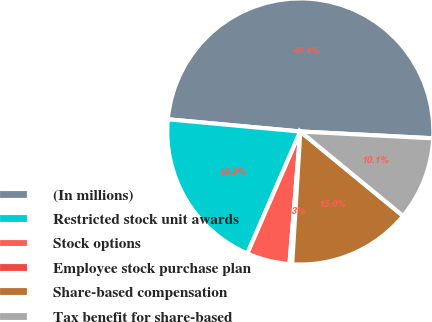Convert chart to OTSL. <chart><loc_0><loc_0><loc_500><loc_500><pie_chart><fcel>(In millions)<fcel>Restricted stock unit awards<fcel>Stock options<fcel>Employee stock purchase plan<fcel>Share-based compensation<fcel>Tax benefit for share-based<nl><fcel>49.36%<fcel>19.94%<fcel>5.22%<fcel>0.32%<fcel>15.03%<fcel>10.13%<nl></chart> 